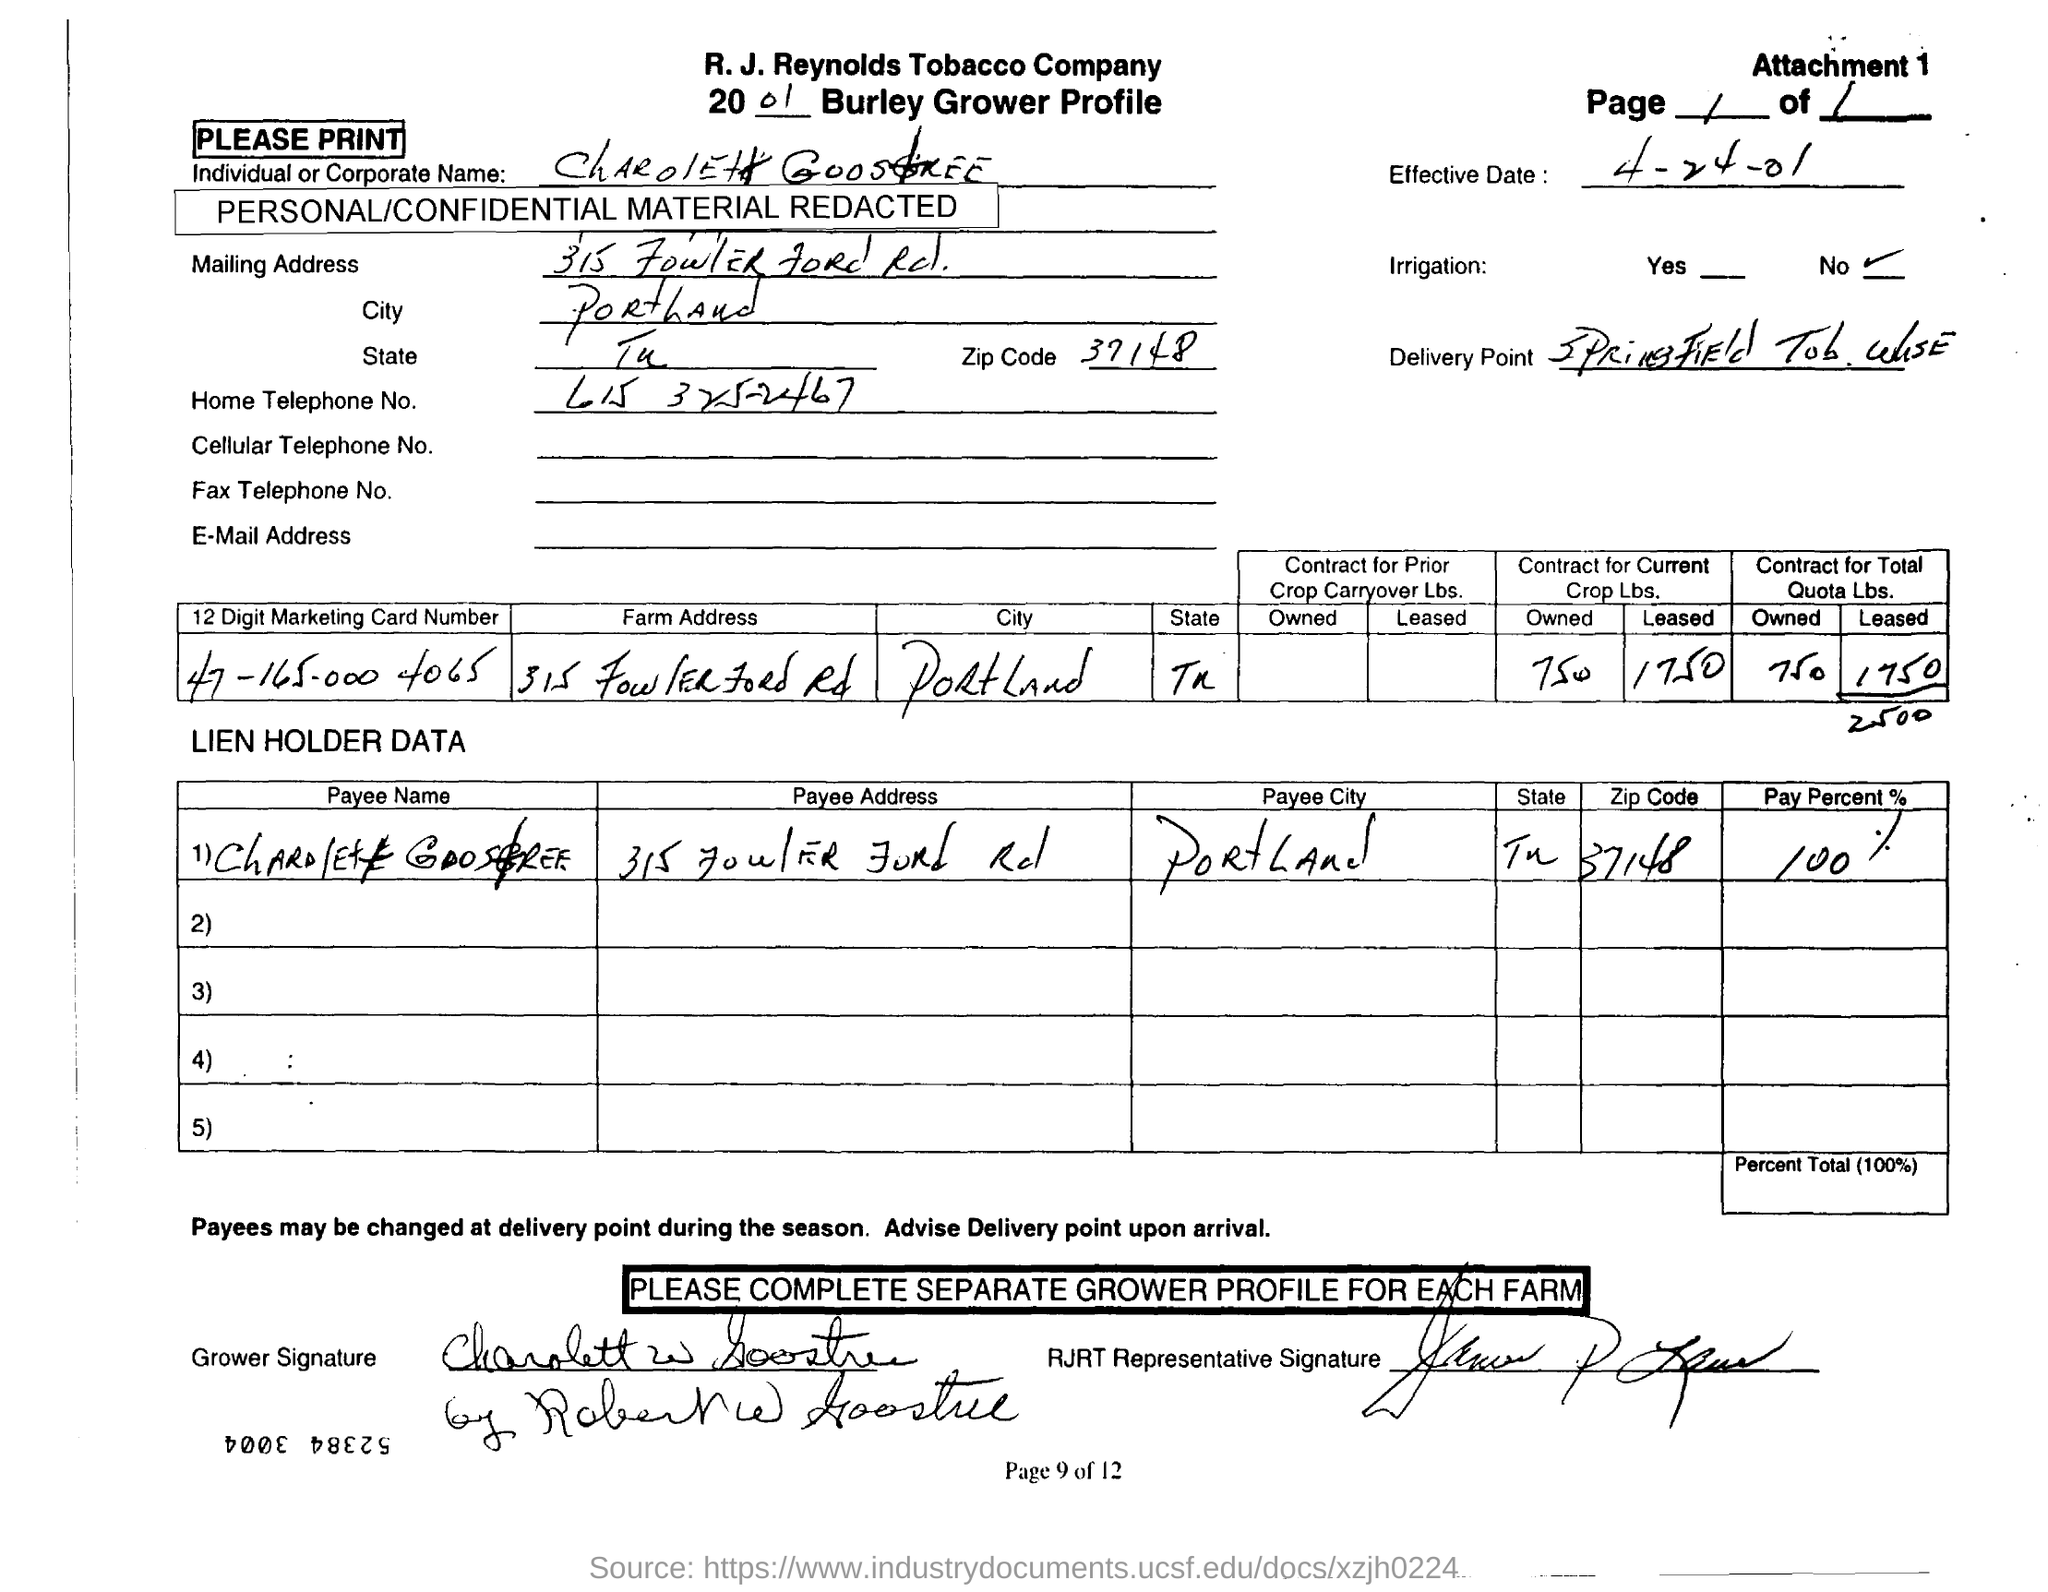What is the effective date mentioned in the document?
Provide a short and direct response. 4-24-01. What is the zipcode given in the address?
Provide a short and direct response. 37148. What is the pay percent given in the document?
Your response must be concise. 100 %. Whose name is given in the 2001 Burley Grower Profile?
Offer a very short reply. Charolett Goostree. What is the home telephone no. of Charolett Goostree?
Give a very brief answer. 615 325-2467. What is the digit marketing card number mentioned in the document?
Ensure brevity in your answer.  47-165-000 4065. What is the payee's name given in the document?
Give a very brief answer. Charolett Goostree. To which city Charolett Goostree belongs to?
Keep it short and to the point. Portland. 